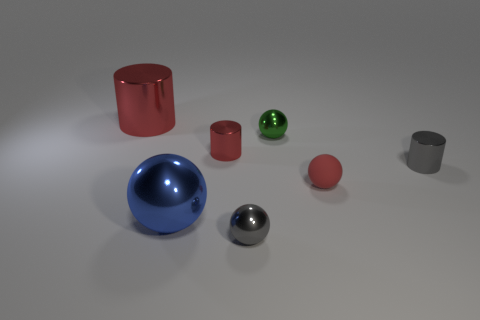Subtract all gray metallic cylinders. How many cylinders are left? 2 Add 2 big green spheres. How many objects exist? 9 Subtract all green balls. How many balls are left? 3 Subtract 2 cylinders. How many cylinders are left? 1 Subtract all gray balls. How many green cylinders are left? 0 Subtract all tiny gray things. Subtract all tiny yellow shiny cubes. How many objects are left? 5 Add 3 small matte balls. How many small matte balls are left? 4 Add 2 gray things. How many gray things exist? 4 Subtract 0 brown spheres. How many objects are left? 7 Subtract all cylinders. How many objects are left? 4 